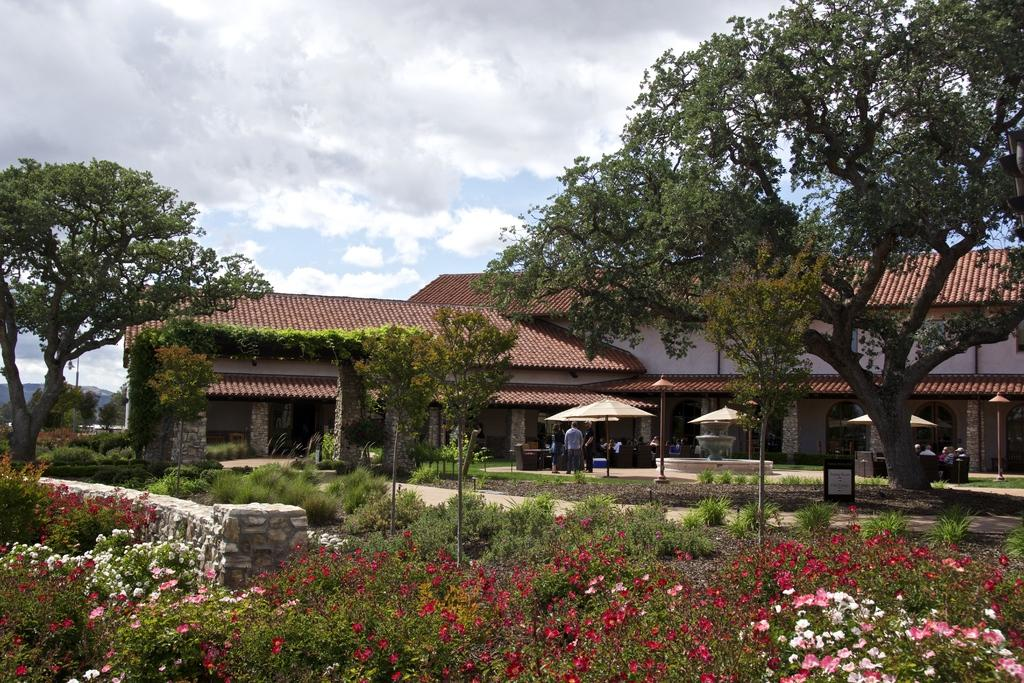What type of structure is in the picture? There is a house in the picture. What features can be seen on the house? The house has windows. What objects are present in the picture besides the house? There are umbrellas, a fountain, poles, trees, flowers, and people in the picture. What can be seen in the background of the picture? The sky is visible in the background of the picture, and there are clouds in the sky. What type of produce is being harvested in the picture? There is no produce or harvesting activity present in the image. What type of park is featured in the picture? There is no park present in the image; it features a house, umbrellas, a fountain, poles, trees, flowers, people, and a sky with clouds. 